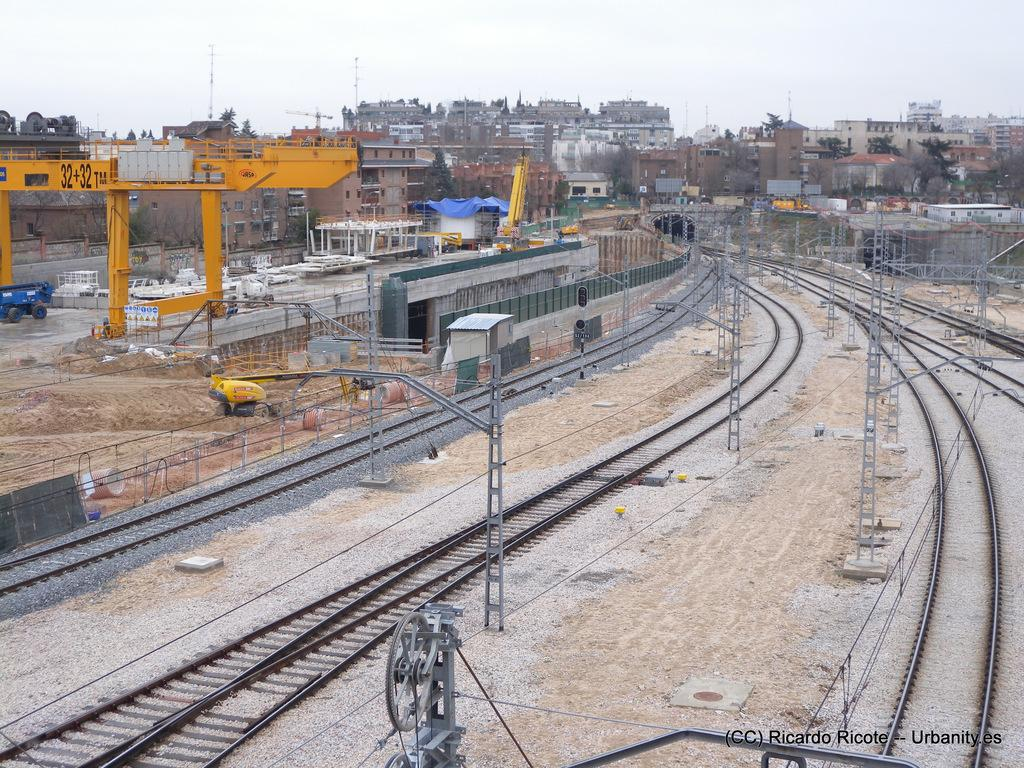<image>
Render a clear and concise summary of the photo. A large yellow metal structure is marked 32+32 TM. 